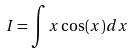Convert formula to latex. <formula><loc_0><loc_0><loc_500><loc_500>I = \int x \cos ( x ) d x</formula> 